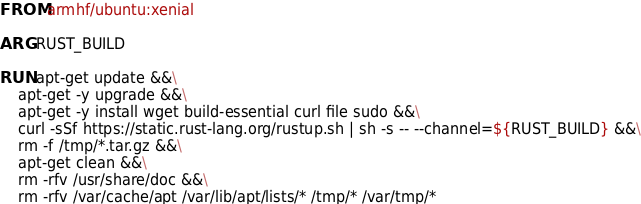<code> <loc_0><loc_0><loc_500><loc_500><_Dockerfile_>FROM armhf/ubuntu:xenial

ARG RUST_BUILD

RUN apt-get update &&\
    apt-get -y upgrade &&\
    apt-get -y install wget build-essential curl file sudo &&\
    curl -sSf https://static.rust-lang.org/rustup.sh | sh -s -- --channel=${RUST_BUILD} &&\
    rm -f /tmp/*.tar.gz &&\
    apt-get clean &&\
    rm -rfv /usr/share/doc &&\
    rm -rfv /var/cache/apt /var/lib/apt/lists/* /tmp/* /var/tmp/*

</code> 